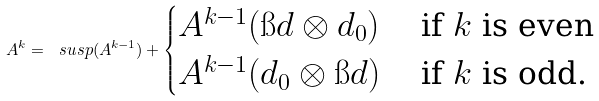Convert formula to latex. <formula><loc_0><loc_0><loc_500><loc_500>A ^ { k } = \ s u s p ( A ^ { k - 1 } ) + \begin{cases} A ^ { k - 1 } ( \i d \otimes d _ { 0 } ) & \text { if $k$ is even} \\ A ^ { k - 1 } ( d _ { 0 } \otimes \i d ) & \text { if $k$ is odd.} \\ \end{cases}</formula> 